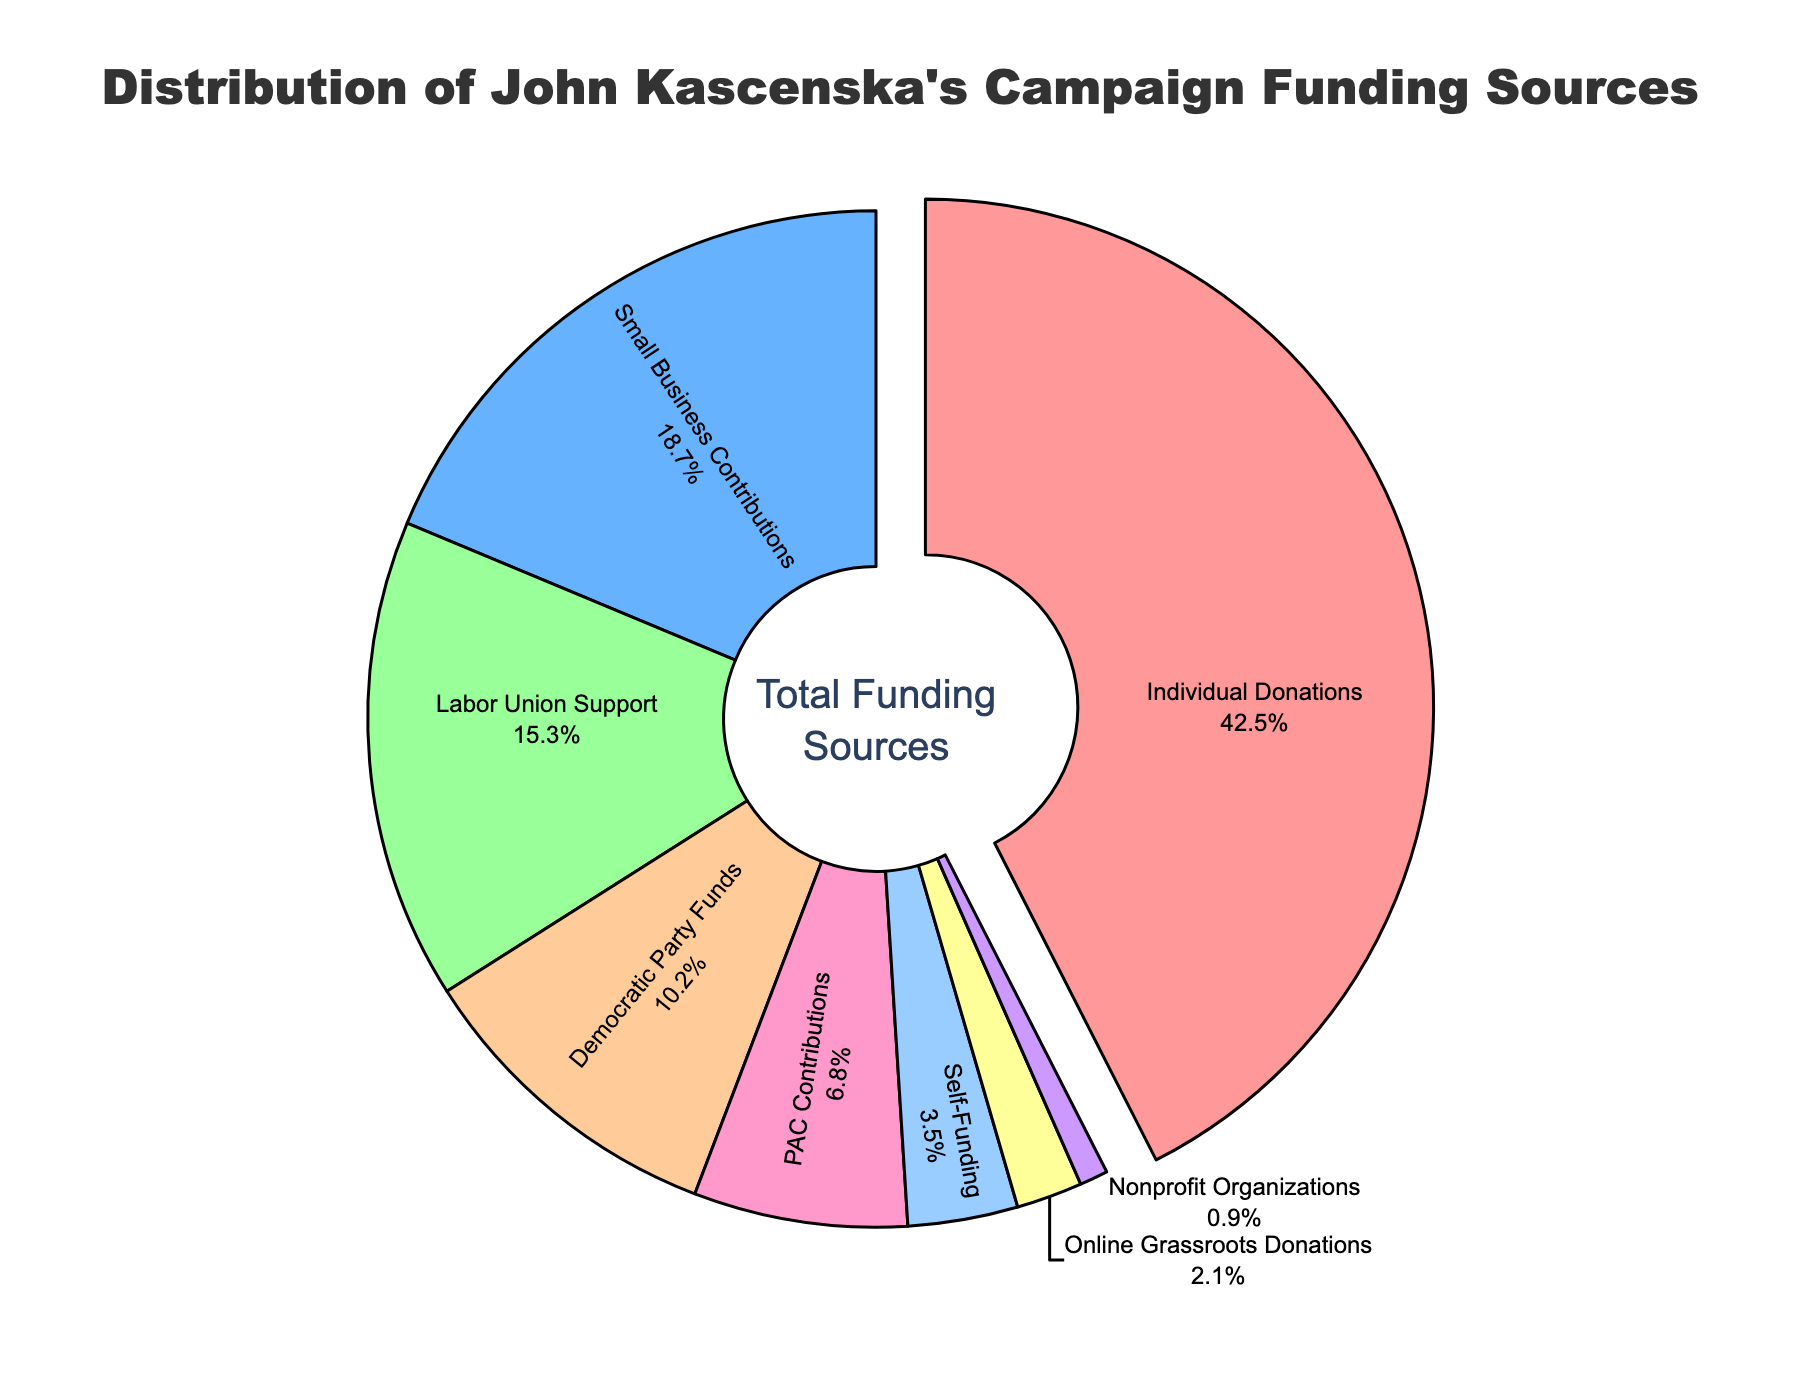Which funding source constitutes the largest percentage of John Kascenska's campaign funding? Looking at the pie chart, the slice pulled out indicates the largest funding source. The label for this slice reads "Individual Donations" with a percentage of 42.5%.
Answer: Individual Donations How much more are Individual Donations compared to Democratic Party Funds? The percentage for Individual Donations is 42.5%, and for Democratic Party Funds, it is 10.2%. Subtracting these gives 42.5 - 10.2 = 32.3%.
Answer: 32.3% Which funding source has the smallest contribution, and what is its percentage? The smallest slice on the pie chart is the one labeled "Nonprofit Organizations," which has a percentage of 0.9%.
Answer: Nonprofit Organizations, 0.9% What is the total percentage of funding coming from Small Business Contributions and Labor Union Support combined? The percentage for Small Business Contributions is 18.7%, and for Labor Union Support, it is 15.3%. Adding these gives 18.7 + 15.3 = 34.0%.
Answer: 34.0% How does the sum of Individual Donations and Small Business Contributions compare to the sum of Labor Union Support and Democratic Party Funds? Individual Donations are 42.5%, and Small Business Contributions are 18.7%. Their sum is 42.5 + 18.7 = 61.2%. Labor Union Support is 15.3%, and Democratic Party Funds are 10.2%. Their sum is 15.3 + 10.2 = 25.5%. Comparing the sums, 61.2% is greater than 25.5%.
Answer: 61.2% is greater Which funding source is represented by the yellow slice in the pie chart? The yellow slice on the pie chart represents the "Online Grassroots Donations" with a percentage of 2.1%.
Answer: Online Grassroots Donations What is the difference in percentages between PAC Contributions and Self-Funding? The percentage for PAC Contributions is 6.8%, and for Self-Funding, it is 3.5%. Subtracting these gives 6.8 - 3.5 = 3.3%.
Answer: 3.3% If the campaign were to increase Online Grassroots Donations by 1%, what would its new percentage be, and how would it compare to the current percentage of Self-Funding? The current percentage for Online Grassroots Donations is 2.1%. Increasing this by 1% gives 2.1 + 1 = 3.1%. The current percentage for Self-Funding is 3.5%. Comparing these, 3.1% is less than 3.5%.
Answer: 3.1%, less How many funding sources exceed a 10% contribution, and which are they? The funding sources exceeding 10% are Individual Donations (42.5%), Small Business Contributions (18.7%), and Labor Union Support (15.3%). There are 3 such funding sources.
Answer: 3, Individual Donations, Small Business Contributions, Labor Union Support 